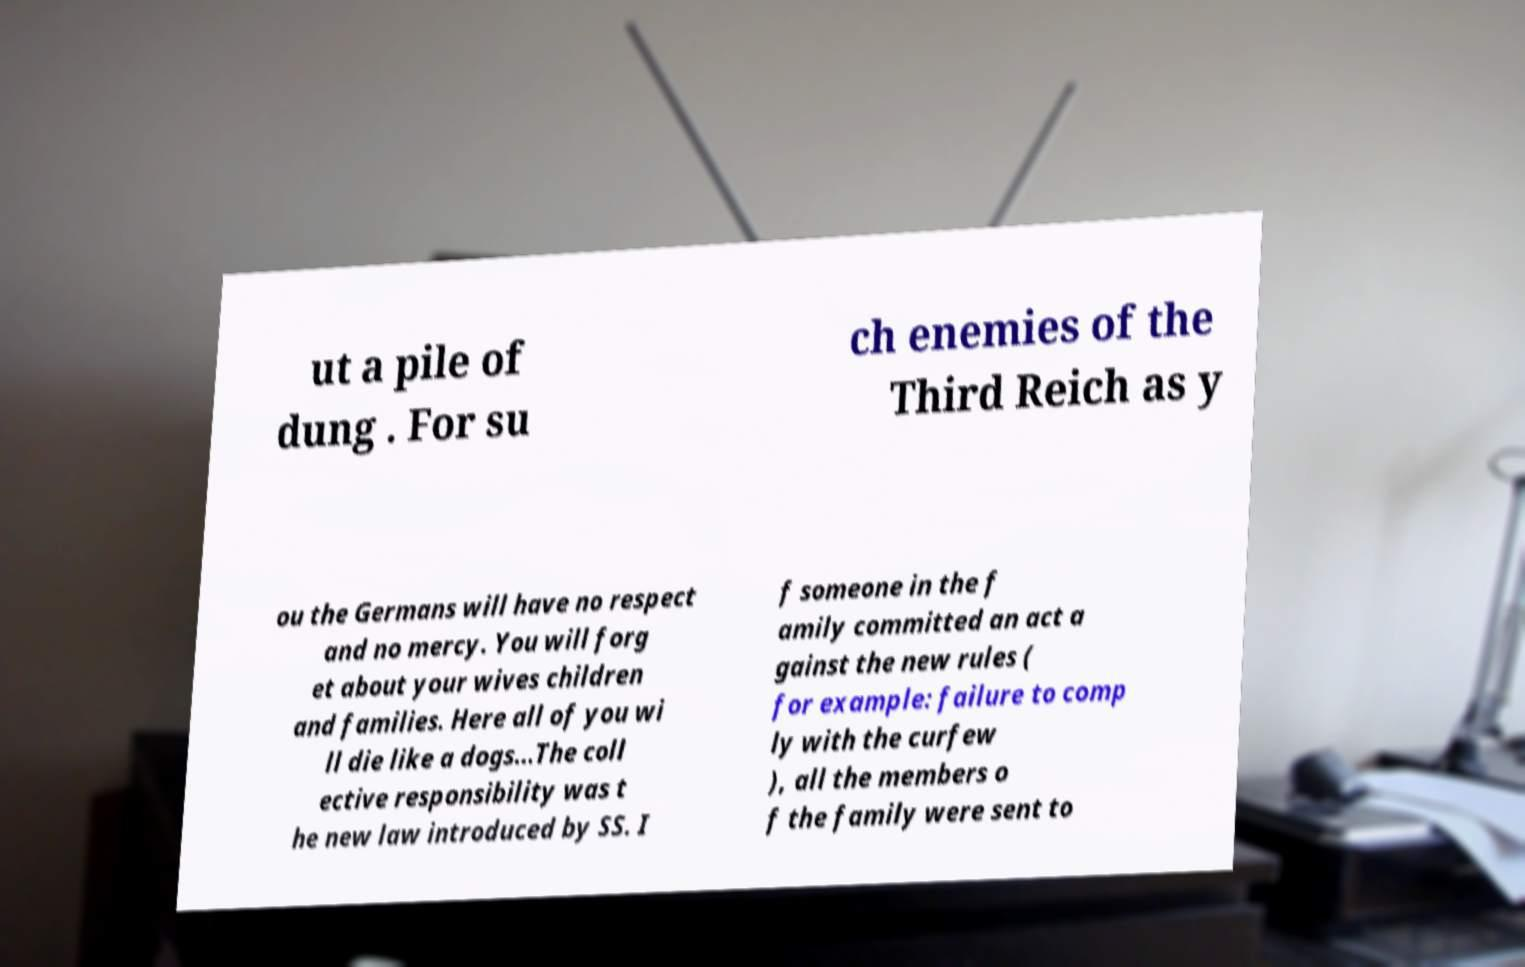I need the written content from this picture converted into text. Can you do that? ut a pile of dung . For su ch enemies of the Third Reich as y ou the Germans will have no respect and no mercy. You will forg et about your wives children and families. Here all of you wi ll die like a dogs...The coll ective responsibility was t he new law introduced by SS. I f someone in the f amily committed an act a gainst the new rules ( for example: failure to comp ly with the curfew ), all the members o f the family were sent to 